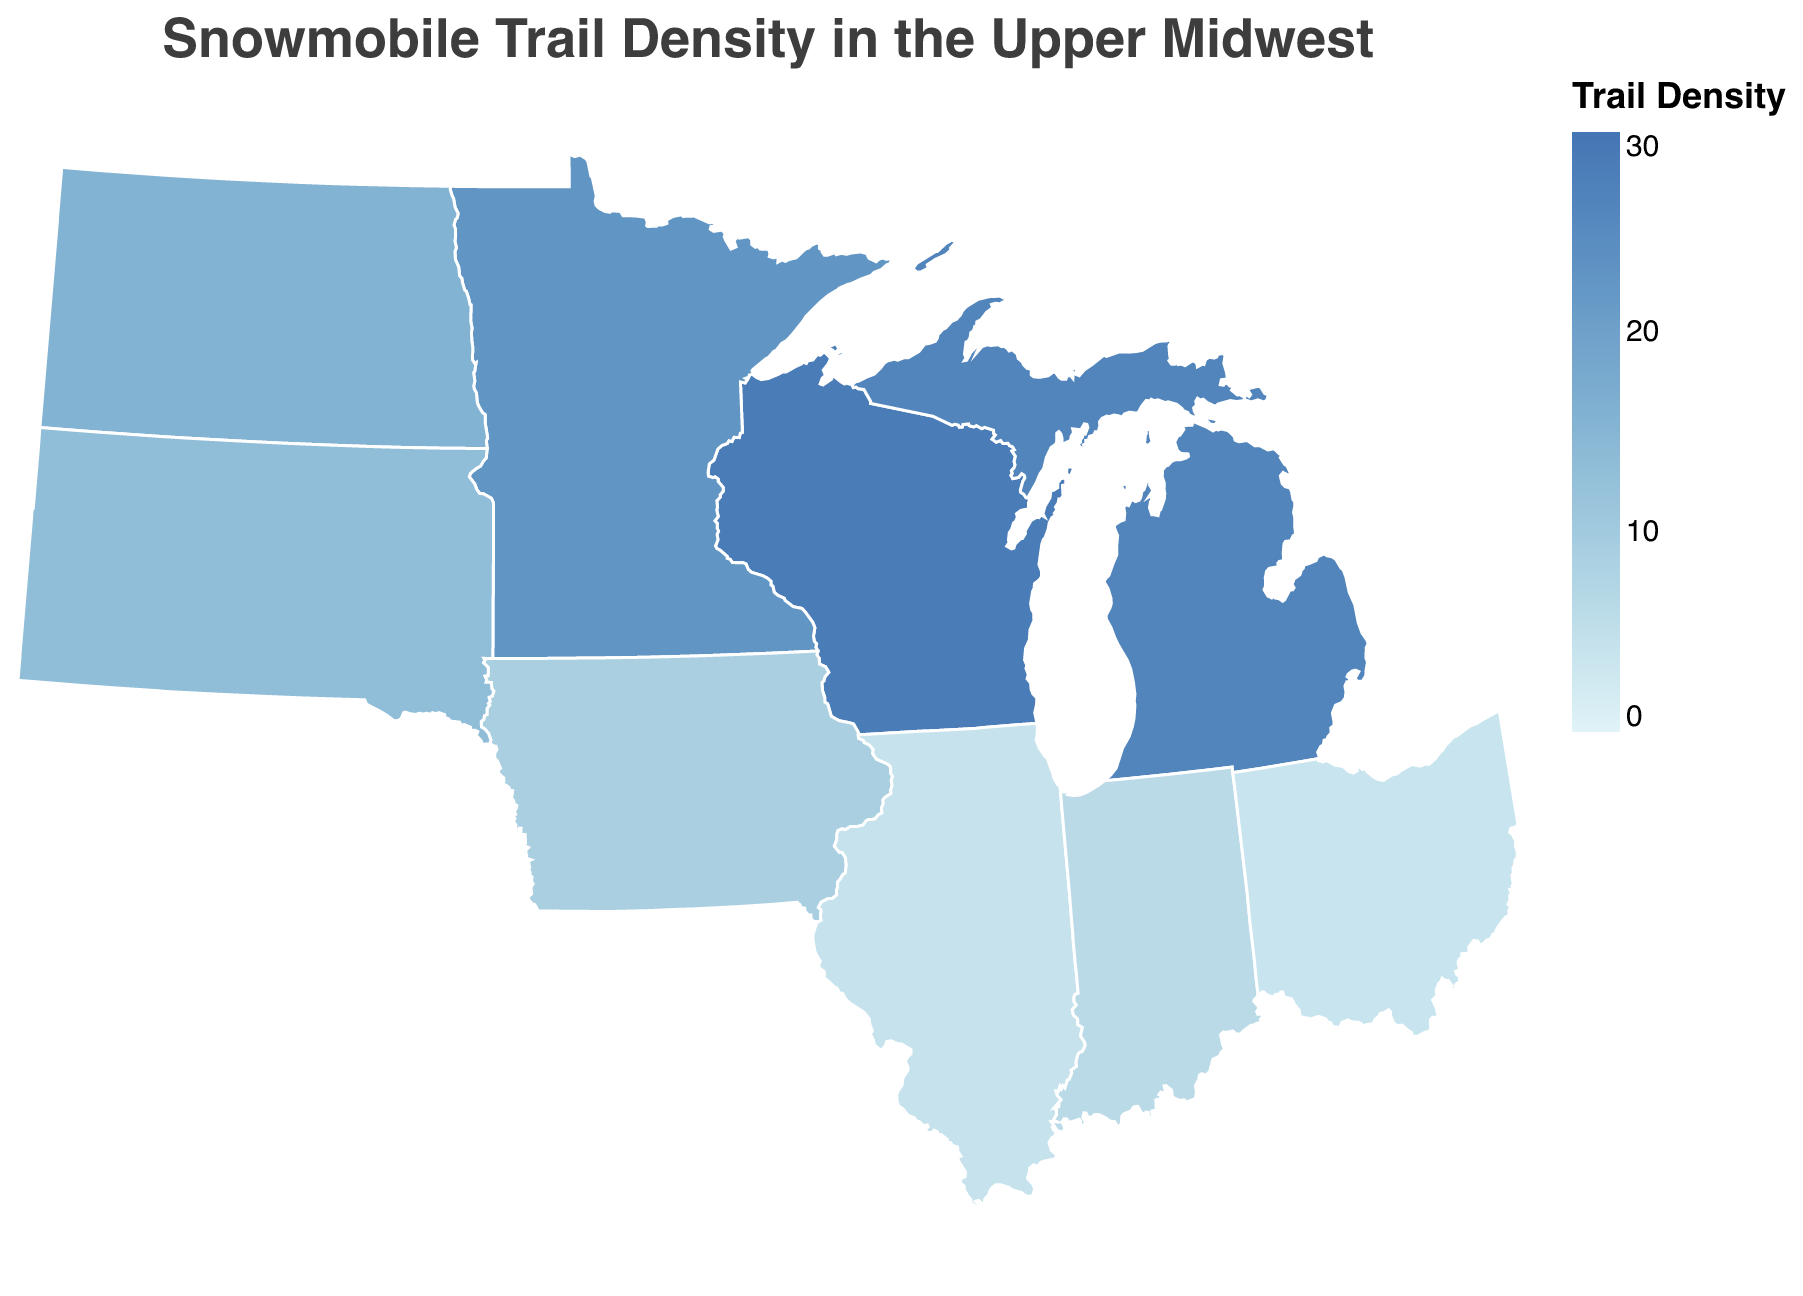What's the title of the figure? The title is usually located at the top of the figure. In this case, it reads "Snowmobile Trail Density in the Upper Midwest."
Answer: Snowmobile Trail Density in the Upper Midwest Which state has the highest snowmobile trail density? By looking at the colors and tooltip on the map, you can see that Wisconsin has the highest trail density, given as 28.5 miles per 100 square miles.
Answer: Wisconsin What is the range of snowmobile trail densities shown on the color scale? The color scale on the figure ranges from the lightest color to the darkest, representing snowmobile trail densities from 0 to 30.
Answer: 0 to 30 Which state has the lowest snowmobile trail density, and what is its value? By inspecting the map and the corresponding tooltip, Ohio is the state with the lowest snowmobile trail density, registering at 3.8 miles per 100 square miles.
Answer: Ohio, 3.8 Compare the snowmobile trail densities of Minnesota and Michigan. Which state has a higher density, and by how much? Looking at the figure, Minnesota's density is 22.7 miles per 100 square miles, while Michigan's is 26.3. Subtracting Minnesota's density from Michigan's gives 26.3 - 22.7 = 3.6.
Answer: Michigan, 3.6 How does Wisconsin's trail density compare to the average trail density of Minnesota and Michigan? First, calculate the average density of Minnesota and Michigan: (22.7 + 26.3) / 2 = 24.5. Comparing this with Wisconsin's density of 28.5, you find that Wisconsin's trail density is 28.5 - 24.5 = 4 miles higher.
Answer: 4 miles higher What is the median snowmobile trail density among the states shown? The ordered densities are 3.8, 4.2, 6.1, 8.9, 13.2, 15.6, 22.7, 26.3, and 28.5. The median value, being the middle one, is 13.2 miles per 100 square miles.
Answer: 13.2 Describe the geographic distribution pattern of snowmobile trail densities in the Upper Midwest. The states with higher densities (Wisconsin, Michigan, and Minnesota) are clustered in the northern part, while states with lower densities (Ohio, Illinois, Indiana) are in the south or east of the region. This pattern is evident from the color gradient in the map.
Answer: Higher in the north, lower in the south and east How many states have a trail density greater than 20 miles per 100 square miles? From the map, Wisconsin, Minnesota, and Michigan have densities greater than 20 miles per 100 square miles, making a total of 3 states.
Answer: 3 